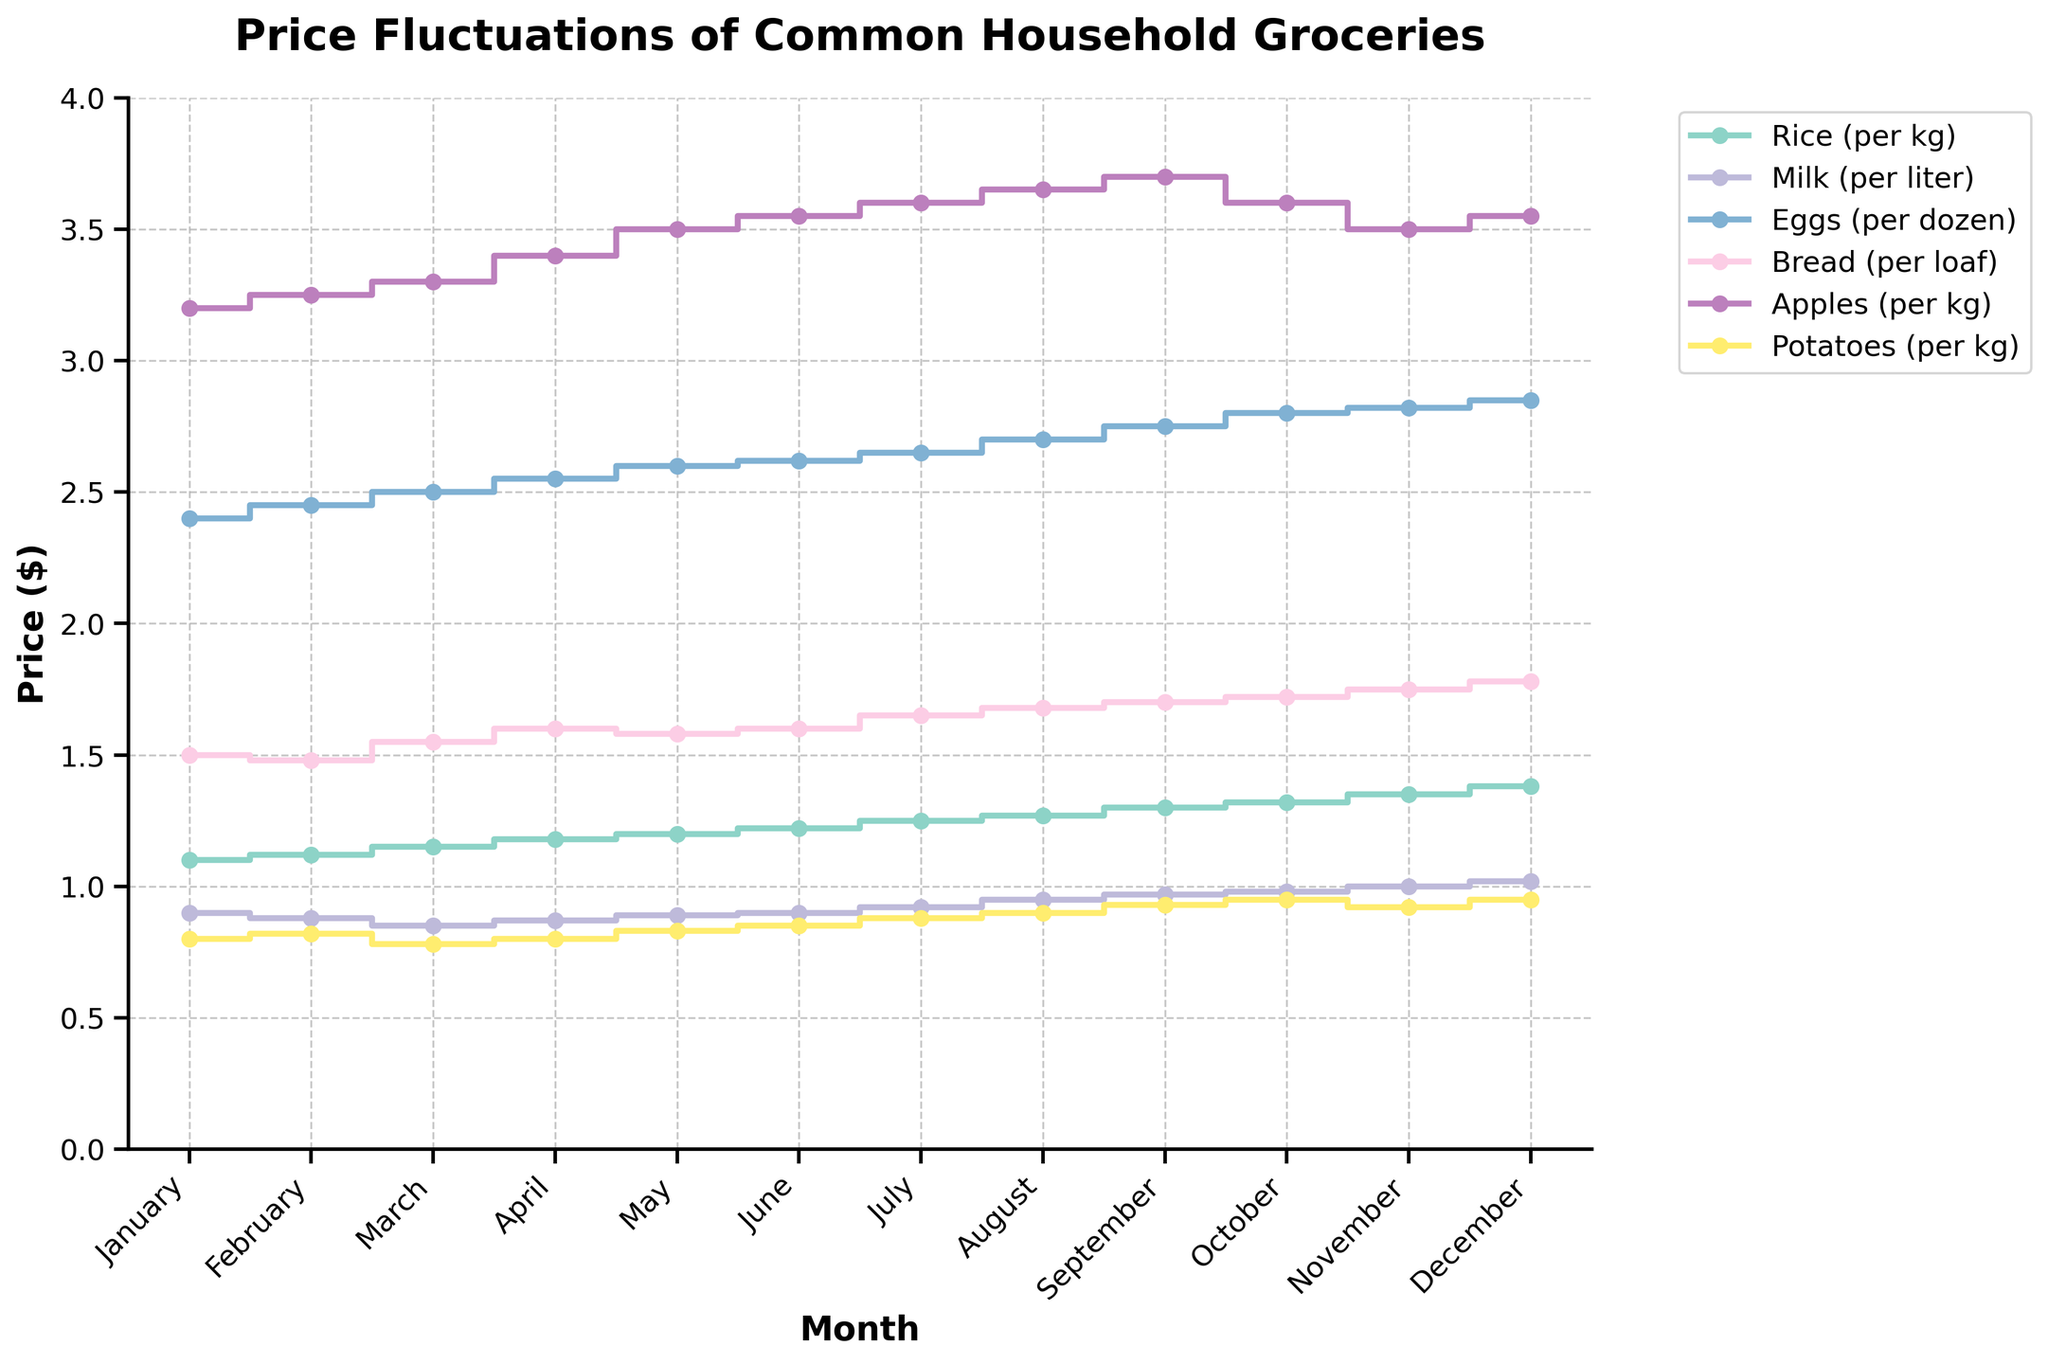what is the title of the plot? The title of the plot is displayed at the top and reads "Price Fluctuations of Common Household Groceries".
Answer: Price Fluctuations of Common Household Groceries What is the price of rice in January? Look at the point for rice in January at the beginning of the corresponding step line; it is marked with a dot at the Y-axis value. For January, this value is 1.10.
Answer: $1.10 Which item had the least variation in price over the year? Examine the step lines' vertical changes. The milk's step line shows relatively minor changes compared to others.
Answer: Milk What is the price difference of apples from January to December? Find and subtract the January price of apples (3.20) from the December price of apples (3.55). \(3.55 - 3.20 = 0.35\).
Answer: $0.35 Which item had the highest price increase from September to October? Compare the step height difference for each item between September and October. Rice increased from 1.30 to 1.32 (+0.02), milk from 0.97 to 0.98 (+0.01), etc. Apples decreased, thus: Bread increased the most (1.70 to 1.72, +0.02).
Answer: Bread At which month do potatoes reach their highest price? Locate the highest vertical point on the potatoes' step line, check its month position. Potatoes' highest price, $0.95, happens in October and December.
Answer: October Do any household groceries decrease in price throughout the year? Observe each step line's overall trend from January to December. Eggs in March (2.50) compared to Eggs in April (2.55) has a continuous increase not decrease, only Apple dropped from September's 3.70 to October's 3.60.
Answer: No What's the average price of bread over the year? Sum the monthly bread prices (1.50 + 1.48 + 1.55 + 1.60 + 1.58 + 1.60 + 1.65 + 1.68 + 1.70 + 1.72 + 1.75 + 1.78) = 19.09, and divide by 12 (the number of months). \( \frac{19.09}{12} \approx 1.59 \).
Answer: $1.59 In which month did rice exceed 1.20 for the first time? Follow the rice price step line until it crosses the 1.20 price level, which happens in June.
Answer: June How much is the difference in the price of potatoes between November and December? Compare the values at the steps' corresponding x-positions for November and December. November is 0.92, and December is 0.95. \(0.95 - 0.92 = 0.03\).
Answer: $0.03 